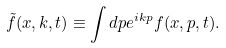Convert formula to latex. <formula><loc_0><loc_0><loc_500><loc_500>\tilde { f } ( x , k , t ) \equiv \int d p e ^ { i k p } f ( x , p , t ) .</formula> 